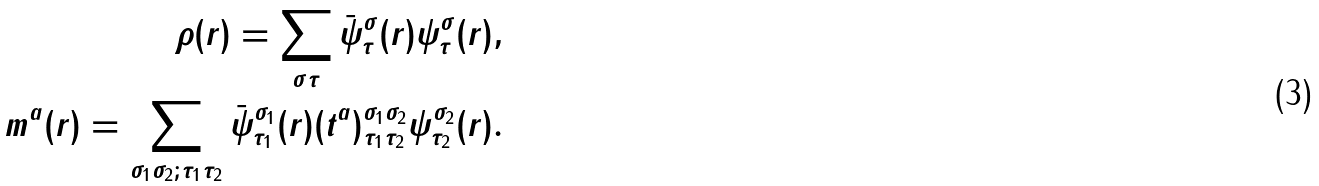Convert formula to latex. <formula><loc_0><loc_0><loc_500><loc_500>\rho ( r ) = \sum _ { \sigma \tau } \bar { \psi } ^ { \sigma } _ { \tau } ( r ) { \psi } ^ { \sigma } _ { \tau } ( r ) , \\ m ^ { a } ( r ) = \sum _ { \sigma _ { 1 } \sigma _ { 2 } ; \tau _ { 1 } \tau _ { 2 } } \bar { \psi } ^ { \sigma _ { 1 } } _ { \tau _ { 1 } } ( r ) ( t ^ { a } ) ^ { \sigma _ { 1 } \sigma _ { 2 } } _ { \tau _ { 1 } \tau _ { 2 } } { \psi } ^ { \sigma _ { 2 } } _ { \tau _ { 2 } } ( r ) .</formula> 